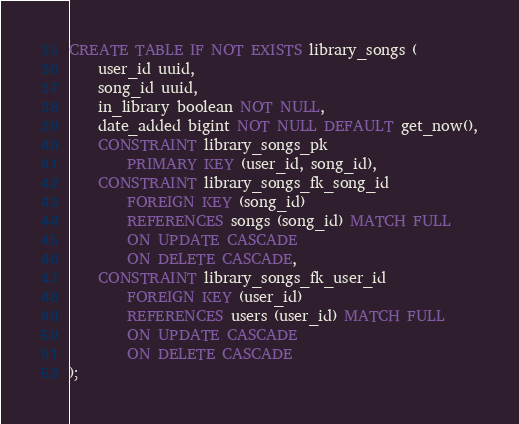<code> <loc_0><loc_0><loc_500><loc_500><_SQL_>CREATE TABLE IF NOT EXISTS library_songs (
	user_id uuid,
	song_id uuid,
	in_library boolean NOT NULL,
	date_added bigint NOT NULL DEFAULT get_now(),
	CONSTRAINT library_songs_pk
		PRIMARY KEY (user_id, song_id),
	CONSTRAINT library_songs_fk_song_id
		FOREIGN KEY (song_id)
		REFERENCES songs (song_id) MATCH FULL
		ON UPDATE CASCADE
		ON DELETE CASCADE,
	CONSTRAINT library_songs_fk_user_id
		FOREIGN KEY (user_id)
		REFERENCES users (user_id) MATCH FULL
		ON UPDATE CASCADE
		ON DELETE CASCADE
);</code> 